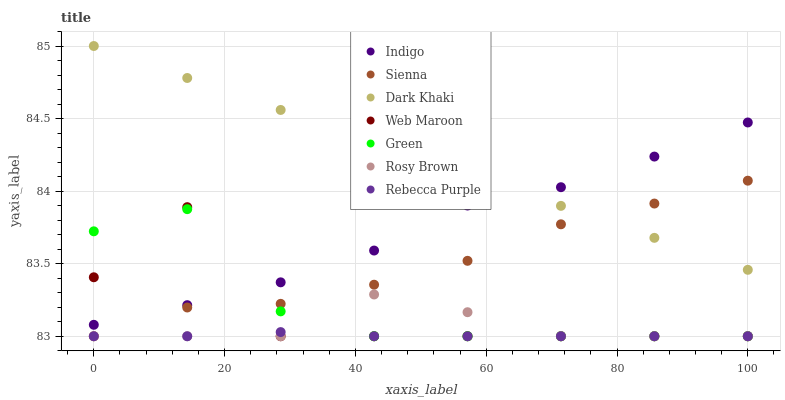Does Rebecca Purple have the minimum area under the curve?
Answer yes or no. Yes. Does Dark Khaki have the maximum area under the curve?
Answer yes or no. Yes. Does Indigo have the minimum area under the curve?
Answer yes or no. No. Does Indigo have the maximum area under the curve?
Answer yes or no. No. Is Dark Khaki the smoothest?
Answer yes or no. Yes. Is Web Maroon the roughest?
Answer yes or no. Yes. Is Indigo the smoothest?
Answer yes or no. No. Is Indigo the roughest?
Answer yes or no. No. Does Rosy Brown have the lowest value?
Answer yes or no. Yes. Does Indigo have the lowest value?
Answer yes or no. No. Does Dark Khaki have the highest value?
Answer yes or no. Yes. Does Indigo have the highest value?
Answer yes or no. No. Is Rosy Brown less than Dark Khaki?
Answer yes or no. Yes. Is Indigo greater than Rebecca Purple?
Answer yes or no. Yes. Does Rebecca Purple intersect Green?
Answer yes or no. Yes. Is Rebecca Purple less than Green?
Answer yes or no. No. Is Rebecca Purple greater than Green?
Answer yes or no. No. Does Rosy Brown intersect Dark Khaki?
Answer yes or no. No. 